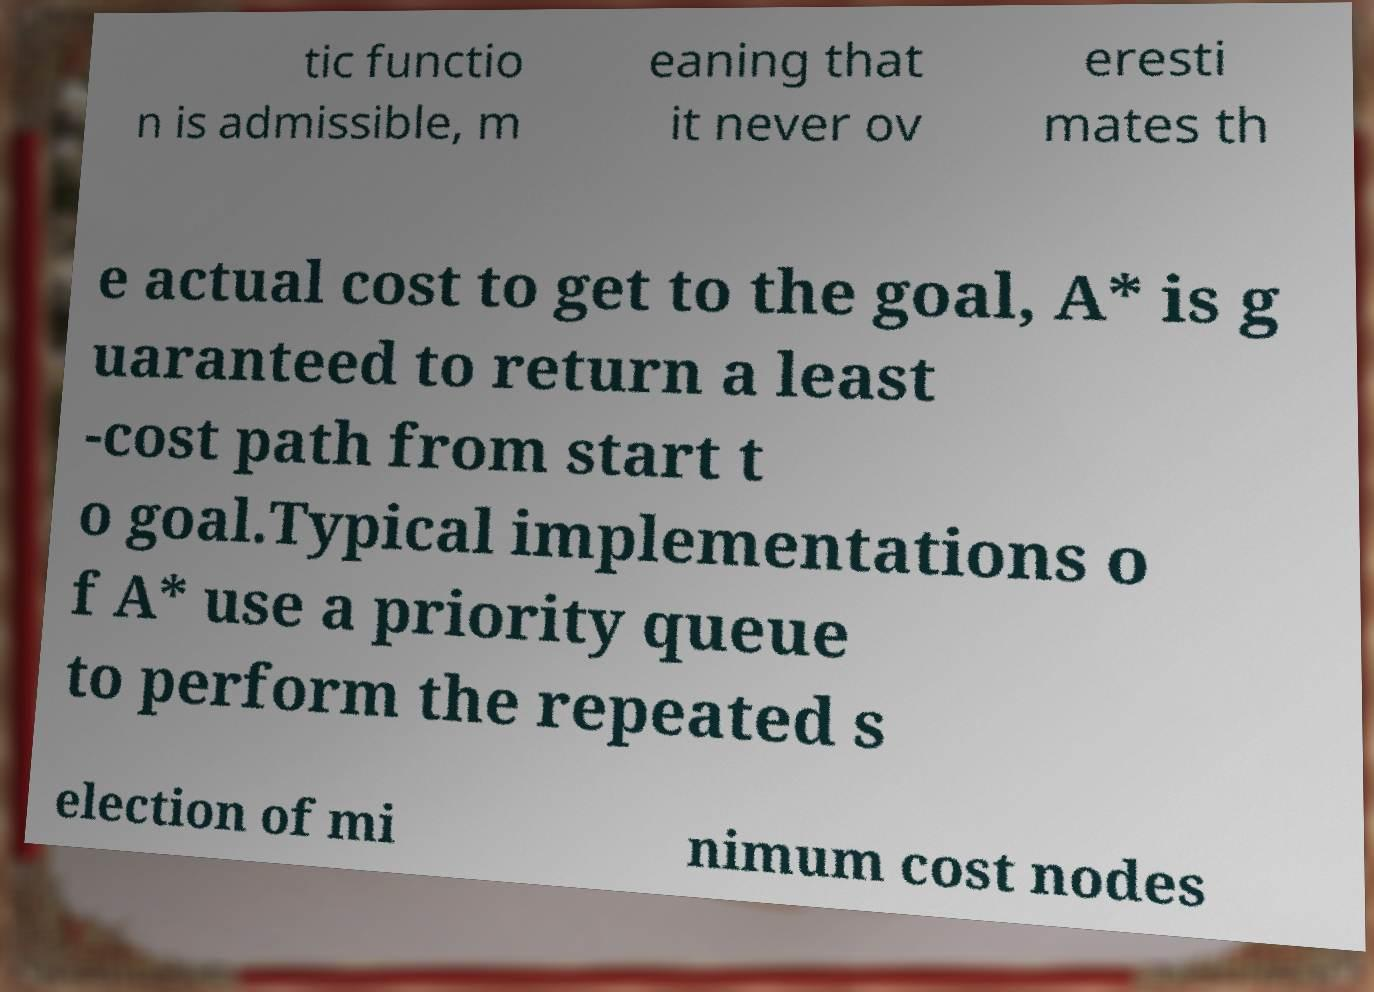For documentation purposes, I need the text within this image transcribed. Could you provide that? tic functio n is admissible, m eaning that it never ov eresti mates th e actual cost to get to the goal, A* is g uaranteed to return a least -cost path from start t o goal.Typical implementations o f A* use a priority queue to perform the repeated s election of mi nimum cost nodes 